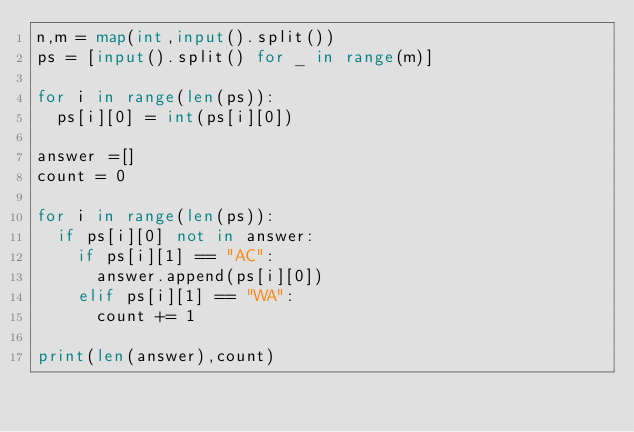<code> <loc_0><loc_0><loc_500><loc_500><_Python_>n,m = map(int,input().split())
ps = [input().split() for _ in range(m)]

for i in range(len(ps)):
  ps[i][0] = int(ps[i][0])

answer =[]
count = 0

for i in range(len(ps)):
  if ps[i][0] not in answer:
    if ps[i][1] == "AC":
      answer.append(ps[i][0])
    elif ps[i][1] == "WA":
      count += 1

print(len(answer),count)</code> 